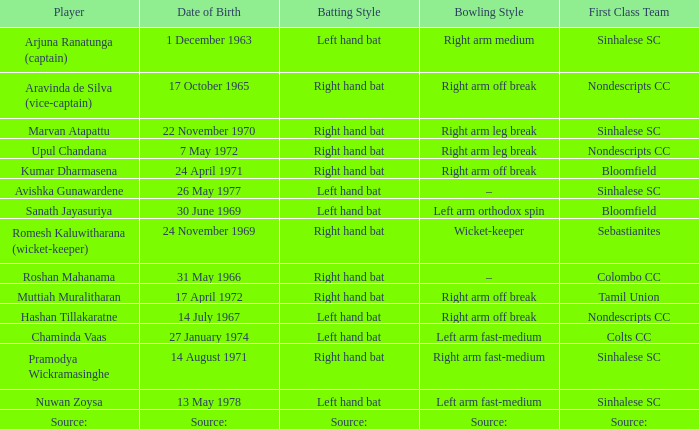Can you parse all the data within this table? {'header': ['Player', 'Date of Birth', 'Batting Style', 'Bowling Style', 'First Class Team'], 'rows': [['Arjuna Ranatunga (captain)', '1 December 1963', 'Left hand bat', 'Right arm medium', 'Sinhalese SC'], ['Aravinda de Silva (vice-captain)', '17 October 1965', 'Right hand bat', 'Right arm off break', 'Nondescripts CC'], ['Marvan Atapattu', '22 November 1970', 'Right hand bat', 'Right arm leg break', 'Sinhalese SC'], ['Upul Chandana', '7 May 1972', 'Right hand bat', 'Right arm leg break', 'Nondescripts CC'], ['Kumar Dharmasena', '24 April 1971', 'Right hand bat', 'Right arm off break', 'Bloomfield'], ['Avishka Gunawardene', '26 May 1977', 'Left hand bat', '–', 'Sinhalese SC'], ['Sanath Jayasuriya', '30 June 1969', 'Left hand bat', 'Left arm orthodox spin', 'Bloomfield'], ['Romesh Kaluwitharana (wicket-keeper)', '24 November 1969', 'Right hand bat', 'Wicket-keeper', 'Sebastianites'], ['Roshan Mahanama', '31 May 1966', 'Right hand bat', '–', 'Colombo CC'], ['Muttiah Muralitharan', '17 April 1972', 'Right hand bat', 'Right arm off break', 'Tamil Union'], ['Hashan Tillakaratne', '14 July 1967', 'Left hand bat', 'Right arm off break', 'Nondescripts CC'], ['Chaminda Vaas', '27 January 1974', 'Left hand bat', 'Left arm fast-medium', 'Colts CC'], ['Pramodya Wickramasinghe', '14 August 1971', 'Right hand bat', 'Right arm fast-medium', 'Sinhalese SC'], ['Nuwan Zoysa', '13 May 1978', 'Left hand bat', 'Left arm fast-medium', 'Sinhalese SC'], ['Source:', 'Source:', 'Source:', 'Source:', 'Source:']]} What first class team does sanath jayasuriya play for? Bloomfield. 